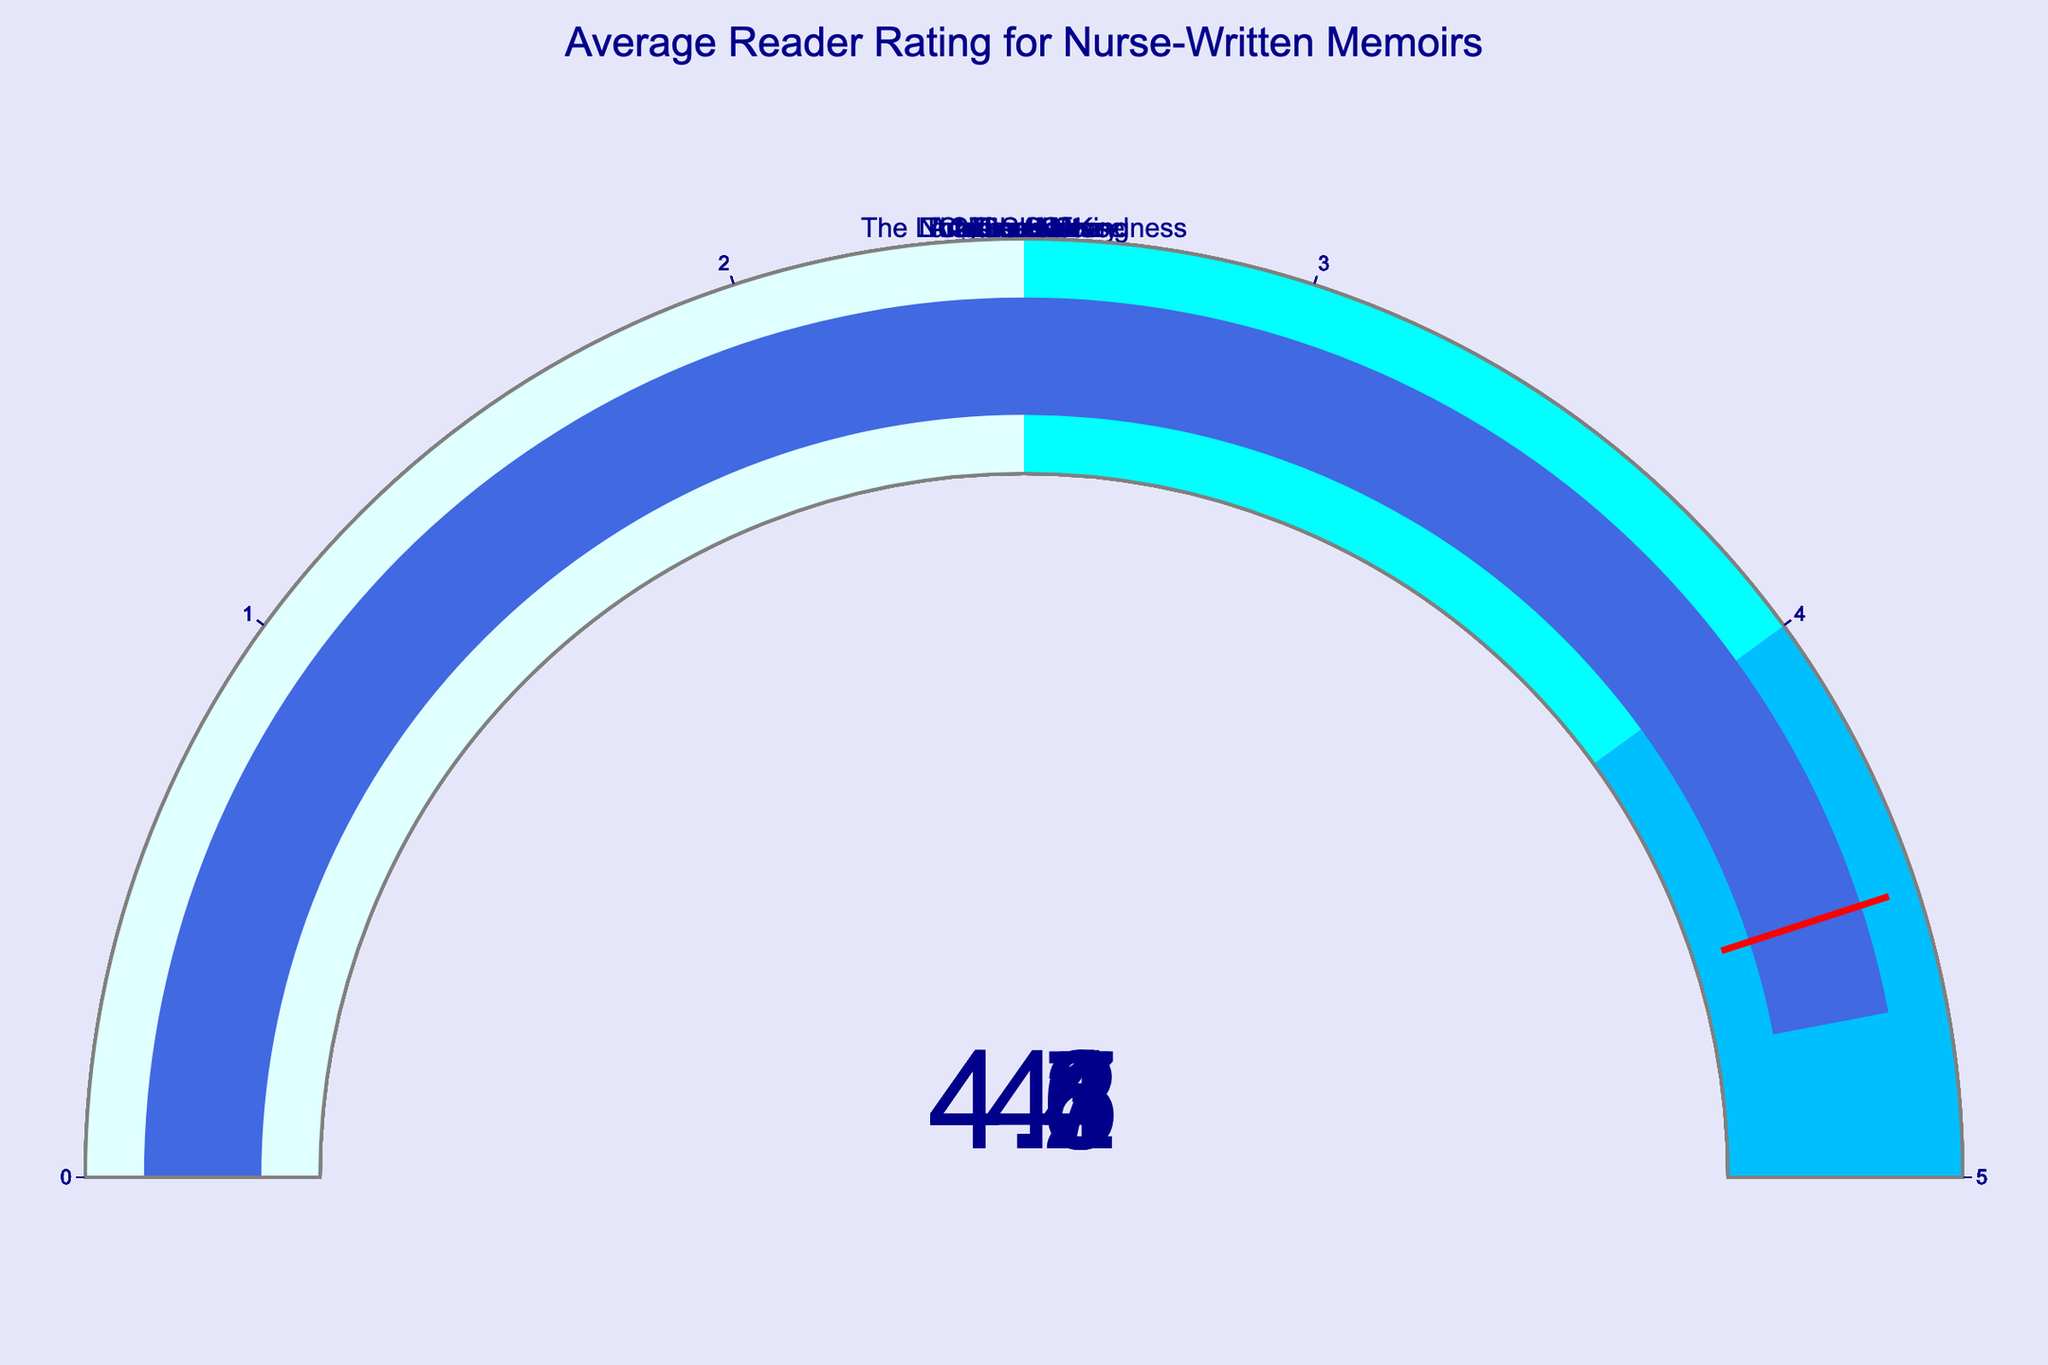What's the title of the figure? The title is usually displayed prominently at the top of the figure. It says "Average Reader Rating for Nurse-Written Memoirs."
Answer: Average Reader Rating for Nurse-Written Memoirs How many books are rated in the figure? Each gauge represents a book, and there are 8 gauges in the figure.
Answer: 8 Which book has the highest average reader rating? Among all the gauges, "In Shock" has the highest value at 4.7.
Answer: In Shock What is the average rating of the book "Critical Care"? The value on the gauge for "Critical Care" is 4.1.
Answer: 4.1 Is there any book with an average rating below 4.0? None of the gauges show a value below 4.0, with "A Nurse's Story" being the lowest at exactly 4.0.
Answer: No Calculate the average rating of all books combined. Sum the ratings: 4.2 + 4.5 + 4.3 + 4.1 + 4.4 + 4.0 + 4.6 + 4.7, which equals 34.8. Divide by the number of books (8): 34.8 / 8 = 4.35.
Answer: 4.35 Which book's average rating is just below 4.5? On inspection, "The Shift" has a rating of 4.3, which is just below 4.5.
Answer: The Shift Compare the average ratings of "Call the Nurse" and "The Good Nurse". Which one is higher? "Call the Nurse" has a rating of 4.2, while "The Good Nurse" has a rating of 4.4. Therefore, "The Good Nurse" has a higher rating.
Answer: The Good Nurse What color region do most of the ratings fall into? The gauge chart has color regions: lightcyan (0-2.5), cyan (2.5-4), and deepskyblue (4-5). Most ratings fall within the deepskyblue region (4-5).
Answer: deepskyblue 